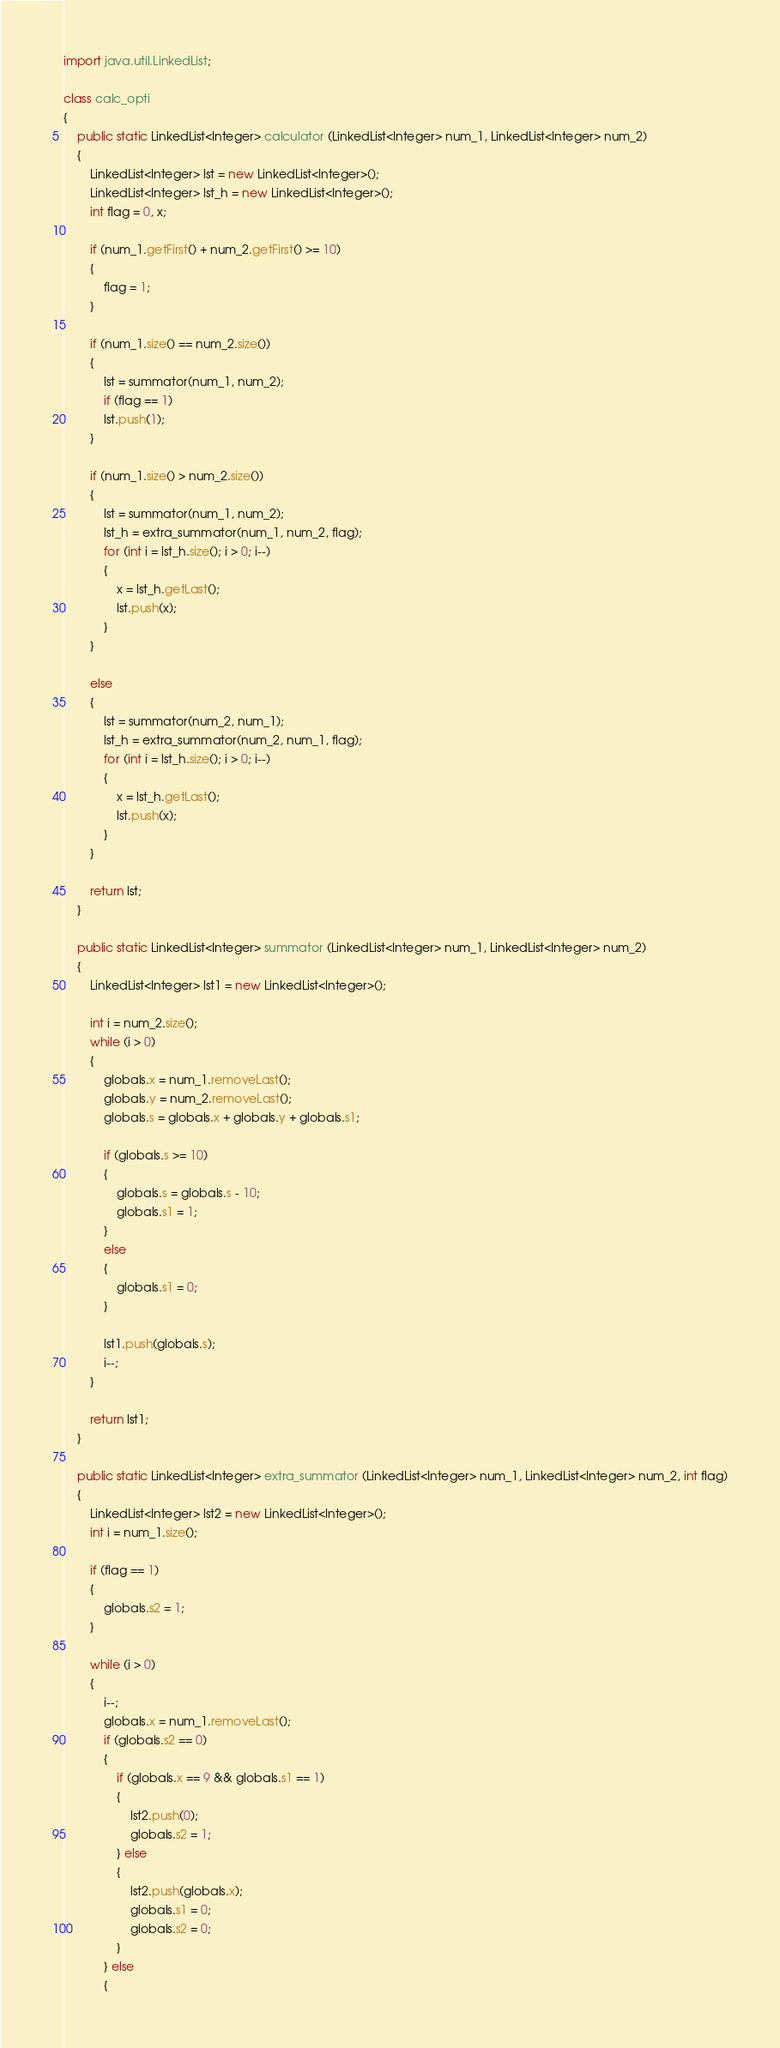<code> <loc_0><loc_0><loc_500><loc_500><_Java_>import java.util.LinkedList;

class calc_opti
{
    public static LinkedList<Integer> calculator (LinkedList<Integer> num_1, LinkedList<Integer> num_2)
    {
        LinkedList<Integer> lst = new LinkedList<Integer>();
        LinkedList<Integer> lst_h = new LinkedList<Integer>();
        int flag = 0, x;

        if (num_1.getFirst() + num_2.getFirst() >= 10)
        {
            flag = 1;
        }

        if (num_1.size() == num_2.size())
        {
            lst = summator(num_1, num_2);
            if (flag == 1)
            lst.push(1);
        }

        if (num_1.size() > num_2.size())
        {
            lst = summator(num_1, num_2);
            lst_h = extra_summator(num_1, num_2, flag);
            for (int i = lst_h.size(); i > 0; i--)
            {
                x = lst_h.getLast();
                lst.push(x);
            }
        }

        else
        {
            lst = summator(num_2, num_1);
            lst_h = extra_summator(num_2, num_1, flag);
            for (int i = lst_h.size(); i > 0; i--)
            {
                x = lst_h.getLast();
                lst.push(x);
            }
        }

        return lst;
    }

    public static LinkedList<Integer> summator (LinkedList<Integer> num_1, LinkedList<Integer> num_2)
    {
        LinkedList<Integer> lst1 = new LinkedList<Integer>();
        
        int i = num_2.size();
        while (i > 0)
        {
            globals.x = num_1.removeLast();
            globals.y = num_2.removeLast();
            globals.s = globals.x + globals.y + globals.s1;
            
            if (globals.s >= 10)
            {
                globals.s = globals.s - 10;
                globals.s1 = 1;
            } 
            else
            {
                globals.s1 = 0;
            }
            
            lst1.push(globals.s);
            i--;
        }
            
        return lst1;
    }

    public static LinkedList<Integer> extra_summator (LinkedList<Integer> num_1, LinkedList<Integer> num_2, int flag)
    {
        LinkedList<Integer> lst2 = new LinkedList<Integer>();
        int i = num_1.size();

        if (flag == 1)
        {
            globals.s2 = 1;
        }
        
        while (i > 0)
        {
            i--;
            globals.x = num_1.removeLast();
            if (globals.s2 == 0)
            {
                if (globals.x == 9 && globals.s1 == 1)
                {
                    lst2.push(0);
                    globals.s2 = 1;
                } else
                {
                    lst2.push(globals.x);
                    globals.s1 = 0;
                    globals.s2 = 0;
                }
            } else
            {</code> 